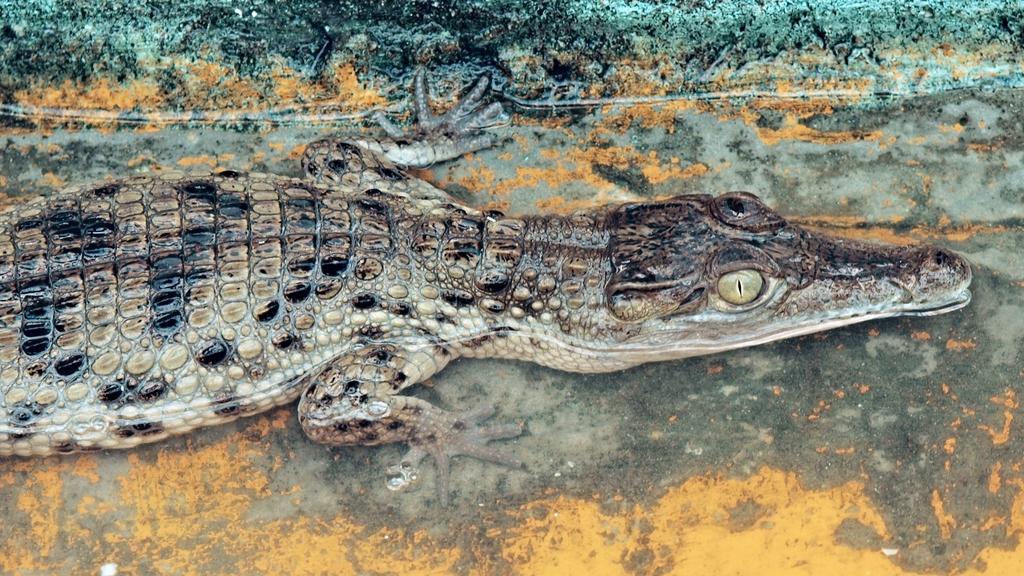Describe this image in one or two sentences. In this image I can see a crocodile. 